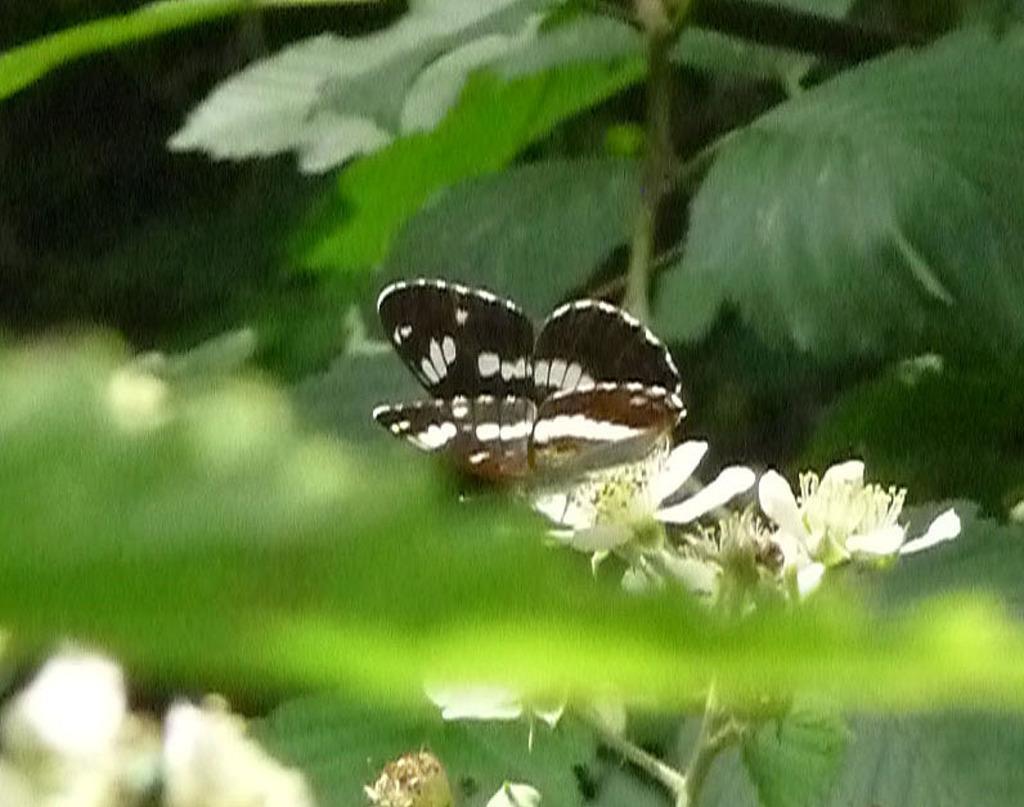Can you describe this image briefly? In the center of the image there is a butterfly on the flower. In the background of the image there are leaves, flowers. 